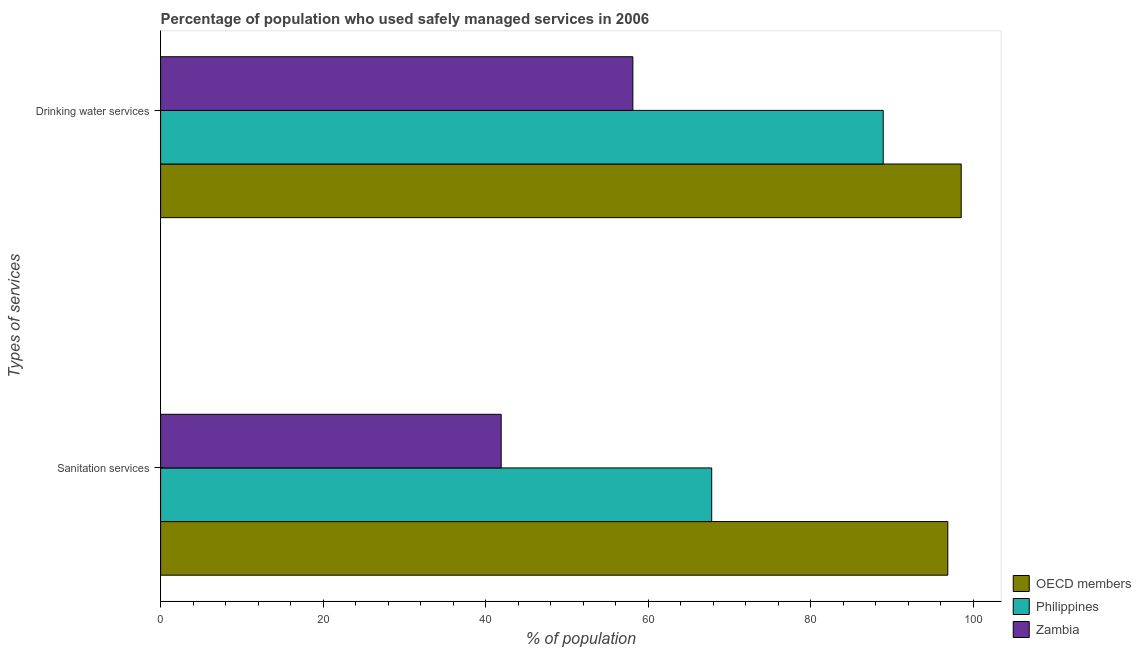Are the number of bars on each tick of the Y-axis equal?
Your response must be concise. Yes. How many bars are there on the 1st tick from the top?
Offer a terse response. 3. How many bars are there on the 1st tick from the bottom?
Make the answer very short. 3. What is the label of the 1st group of bars from the top?
Ensure brevity in your answer.  Drinking water services. What is the percentage of population who used sanitation services in Philippines?
Make the answer very short. 67.8. Across all countries, what is the maximum percentage of population who used drinking water services?
Provide a succinct answer. 98.49. Across all countries, what is the minimum percentage of population who used sanitation services?
Ensure brevity in your answer.  41.9. In which country was the percentage of population who used drinking water services minimum?
Keep it short and to the point. Zambia. What is the total percentage of population who used drinking water services in the graph?
Provide a succinct answer. 245.49. What is the difference between the percentage of population who used drinking water services in Zambia and that in OECD members?
Ensure brevity in your answer.  -40.39. What is the difference between the percentage of population who used sanitation services in Philippines and the percentage of population who used drinking water services in OECD members?
Provide a short and direct response. -30.69. What is the average percentage of population who used drinking water services per country?
Your answer should be very brief. 81.83. What is the difference between the percentage of population who used drinking water services and percentage of population who used sanitation services in Zambia?
Keep it short and to the point. 16.2. What is the ratio of the percentage of population who used sanitation services in OECD members to that in Zambia?
Your answer should be very brief. 2.31. What does the 1st bar from the bottom in Sanitation services represents?
Ensure brevity in your answer.  OECD members. How many bars are there?
Give a very brief answer. 6. Are all the bars in the graph horizontal?
Keep it short and to the point. Yes. Are the values on the major ticks of X-axis written in scientific E-notation?
Your response must be concise. No. Does the graph contain grids?
Offer a terse response. No. How many legend labels are there?
Provide a short and direct response. 3. What is the title of the graph?
Offer a terse response. Percentage of population who used safely managed services in 2006. Does "Andorra" appear as one of the legend labels in the graph?
Provide a succinct answer. No. What is the label or title of the X-axis?
Offer a very short reply. % of population. What is the label or title of the Y-axis?
Provide a succinct answer. Types of services. What is the % of population of OECD members in Sanitation services?
Offer a terse response. 96.85. What is the % of population of Philippines in Sanitation services?
Offer a terse response. 67.8. What is the % of population in Zambia in Sanitation services?
Provide a short and direct response. 41.9. What is the % of population of OECD members in Drinking water services?
Ensure brevity in your answer.  98.49. What is the % of population of Philippines in Drinking water services?
Make the answer very short. 88.9. What is the % of population of Zambia in Drinking water services?
Offer a very short reply. 58.1. Across all Types of services, what is the maximum % of population of OECD members?
Provide a short and direct response. 98.49. Across all Types of services, what is the maximum % of population in Philippines?
Provide a short and direct response. 88.9. Across all Types of services, what is the maximum % of population of Zambia?
Your answer should be very brief. 58.1. Across all Types of services, what is the minimum % of population of OECD members?
Your answer should be compact. 96.85. Across all Types of services, what is the minimum % of population in Philippines?
Make the answer very short. 67.8. Across all Types of services, what is the minimum % of population in Zambia?
Provide a succinct answer. 41.9. What is the total % of population in OECD members in the graph?
Provide a succinct answer. 195.34. What is the total % of population in Philippines in the graph?
Ensure brevity in your answer.  156.7. What is the difference between the % of population in OECD members in Sanitation services and that in Drinking water services?
Ensure brevity in your answer.  -1.65. What is the difference between the % of population in Philippines in Sanitation services and that in Drinking water services?
Your answer should be compact. -21.1. What is the difference between the % of population of Zambia in Sanitation services and that in Drinking water services?
Your answer should be very brief. -16.2. What is the difference between the % of population in OECD members in Sanitation services and the % of population in Philippines in Drinking water services?
Give a very brief answer. 7.95. What is the difference between the % of population in OECD members in Sanitation services and the % of population in Zambia in Drinking water services?
Give a very brief answer. 38.75. What is the difference between the % of population in Philippines in Sanitation services and the % of population in Zambia in Drinking water services?
Your answer should be very brief. 9.7. What is the average % of population in OECD members per Types of services?
Provide a short and direct response. 97.67. What is the average % of population in Philippines per Types of services?
Ensure brevity in your answer.  78.35. What is the difference between the % of population of OECD members and % of population of Philippines in Sanitation services?
Give a very brief answer. 29.05. What is the difference between the % of population in OECD members and % of population in Zambia in Sanitation services?
Offer a very short reply. 54.95. What is the difference between the % of population in Philippines and % of population in Zambia in Sanitation services?
Keep it short and to the point. 25.9. What is the difference between the % of population of OECD members and % of population of Philippines in Drinking water services?
Offer a very short reply. 9.59. What is the difference between the % of population of OECD members and % of population of Zambia in Drinking water services?
Your answer should be compact. 40.39. What is the difference between the % of population of Philippines and % of population of Zambia in Drinking water services?
Your answer should be compact. 30.8. What is the ratio of the % of population in OECD members in Sanitation services to that in Drinking water services?
Provide a succinct answer. 0.98. What is the ratio of the % of population in Philippines in Sanitation services to that in Drinking water services?
Your answer should be compact. 0.76. What is the ratio of the % of population in Zambia in Sanitation services to that in Drinking water services?
Provide a short and direct response. 0.72. What is the difference between the highest and the second highest % of population of OECD members?
Give a very brief answer. 1.65. What is the difference between the highest and the second highest % of population in Philippines?
Your answer should be very brief. 21.1. What is the difference between the highest and the lowest % of population of OECD members?
Your response must be concise. 1.65. What is the difference between the highest and the lowest % of population in Philippines?
Give a very brief answer. 21.1. What is the difference between the highest and the lowest % of population of Zambia?
Ensure brevity in your answer.  16.2. 